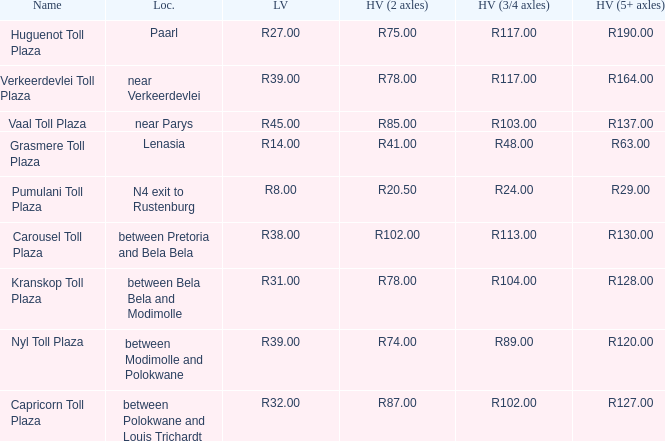What is the name of the plaza where the told for heavy vehicles with 2 axles is r20.50? Pumulani Toll Plaza. 